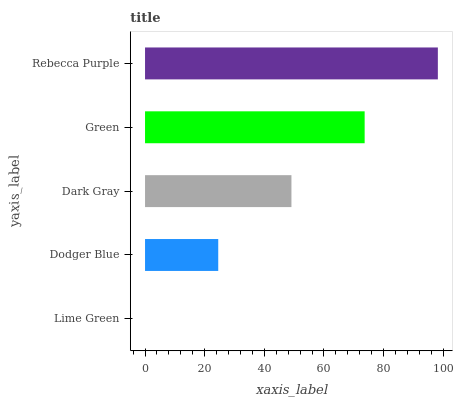Is Lime Green the minimum?
Answer yes or no. Yes. Is Rebecca Purple the maximum?
Answer yes or no. Yes. Is Dodger Blue the minimum?
Answer yes or no. No. Is Dodger Blue the maximum?
Answer yes or no. No. Is Dodger Blue greater than Lime Green?
Answer yes or no. Yes. Is Lime Green less than Dodger Blue?
Answer yes or no. Yes. Is Lime Green greater than Dodger Blue?
Answer yes or no. No. Is Dodger Blue less than Lime Green?
Answer yes or no. No. Is Dark Gray the high median?
Answer yes or no. Yes. Is Dark Gray the low median?
Answer yes or no. Yes. Is Rebecca Purple the high median?
Answer yes or no. No. Is Green the low median?
Answer yes or no. No. 